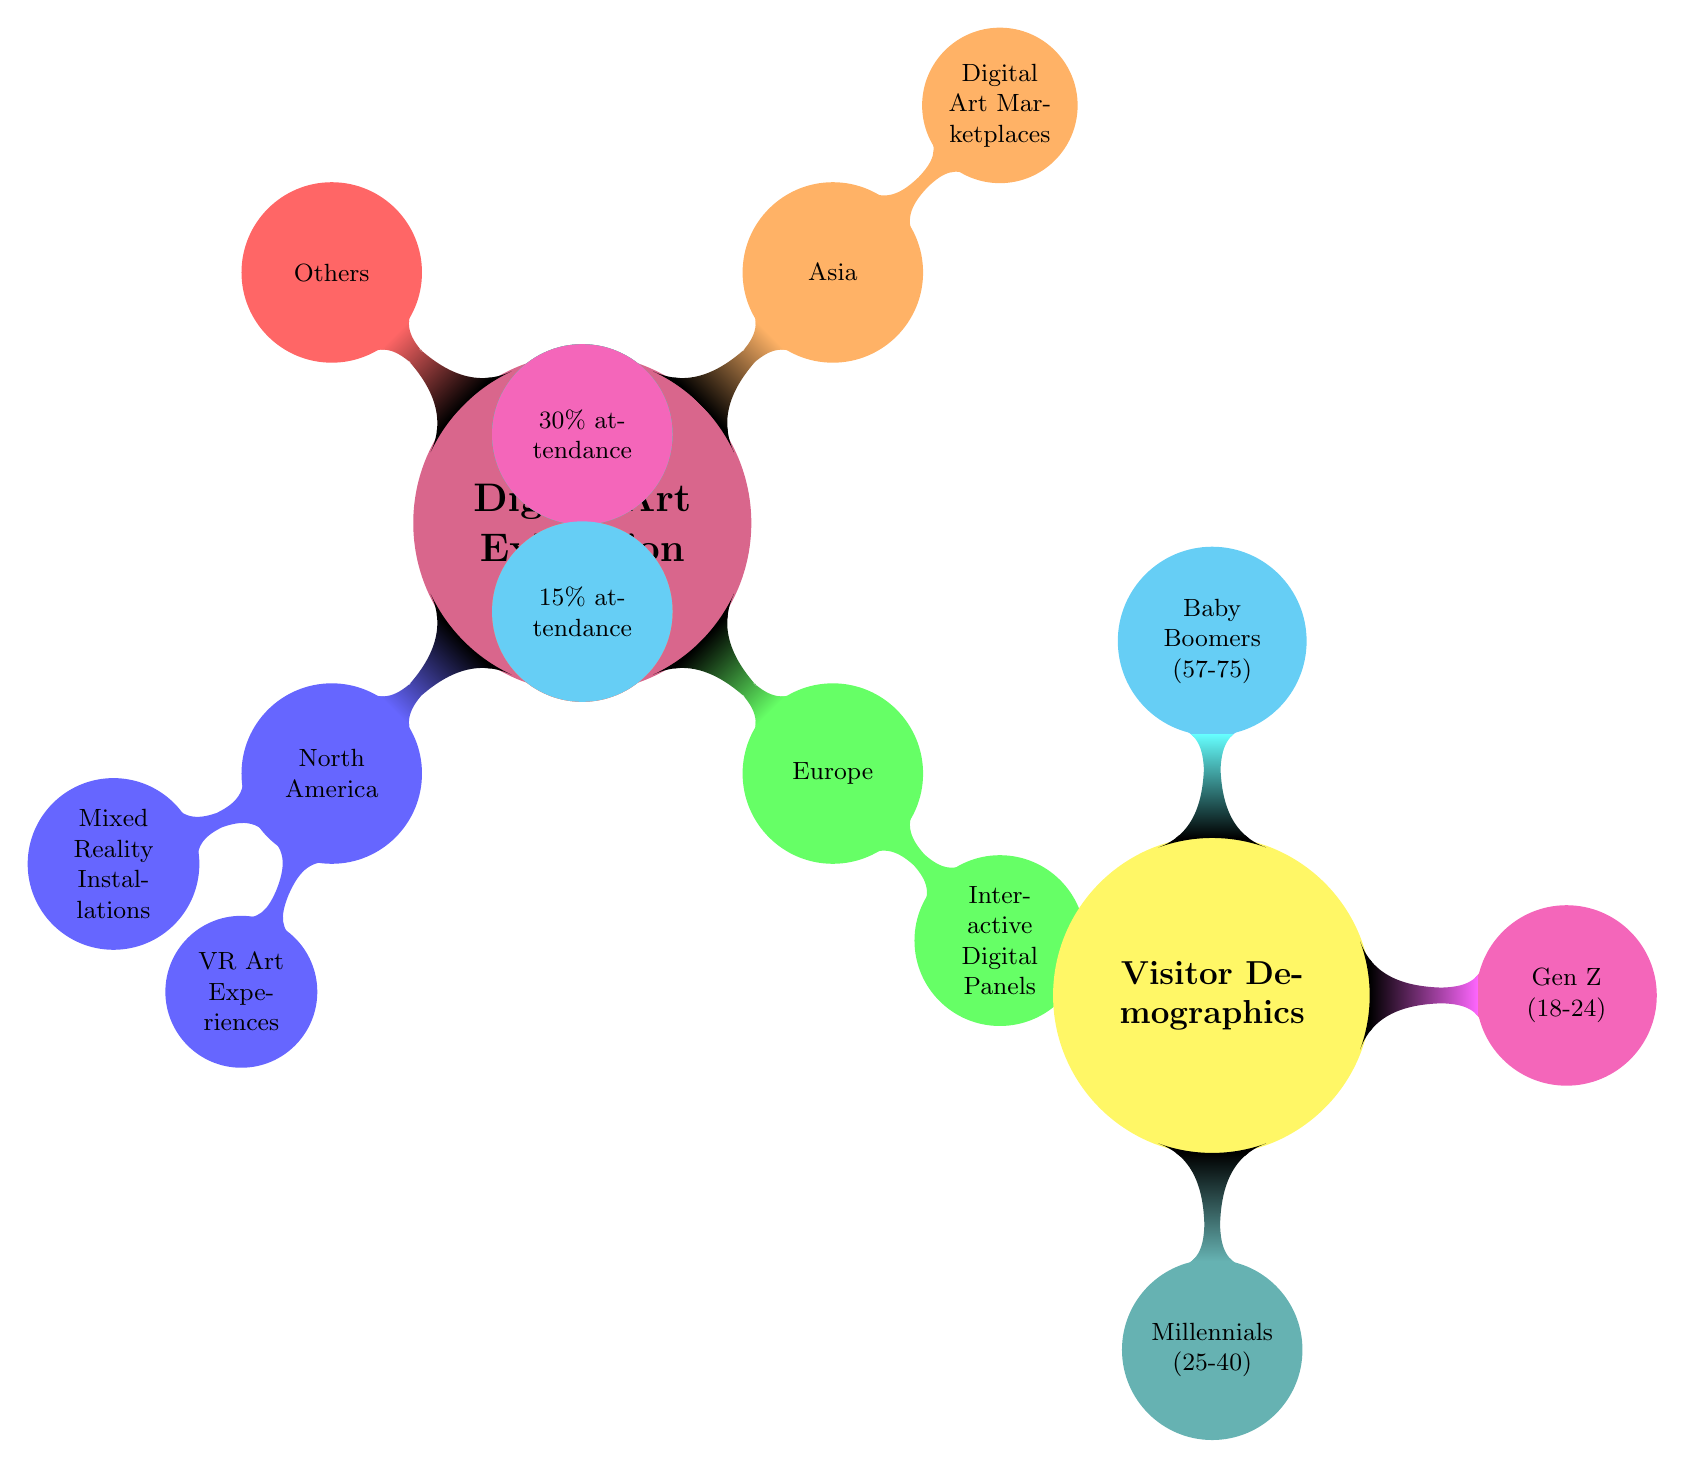What is the global share percentage for North America? The diagram shows North America as having a global share of 40%. This is indicated directly in the node representing North America.
Answer: 40% What type of installations are popular in North America? The node for North America indicates that Mixed Reality Installations are the popular trend, which is labeled right next to that node.
Answer: Mixed Reality Installations What is the global share percentage for Europe? The diagram explicitly states that Europe has a global share of 35%, indicated in the node representing Europe.
Answer: 35% Which demographic has the highest attendance percentage? The diagram shows that Millennials (25-40) have the highest attendance at 45%, located within the Visitor Demographics section, which is directly indicated on the node.
Answer: Millennials (25-40) What percentage of visitors are Baby Boomers? The diagram indicates that Baby Boomers (57-75) account for 15% of attendance, as specified in the respective node.
Answer: 15% How many regions are detailed in the digital art exhibition trends section? The diagram presents four regions in the Global Digital Art Exhibition Trends section: North America, Europe, Asia, and Others. This information can be counted directly from the nodes under the main topic.
Answer: Four Which region has the emphasis on commercial focus? The Asia node specifies that it focuses on Digital Art Marketplaces, which is described as having a commercial focus. Hence, Asia is the region with this emphasis.
Answer: Asia What is the total percentage share covered by Asia and Others? The Asia section has a share of 20% while Others has 5%, so combining these yields a total of 25%. The percentages can be directly retrieved from their respective nodes and summed.
Answer: 25% Which demographic has the least attendance? The diagram shows that Baby Boomers (57-75) represent the least attendance with 15%, as noted under Visitor Demographics.
Answer: Baby Boomers (57-75) 